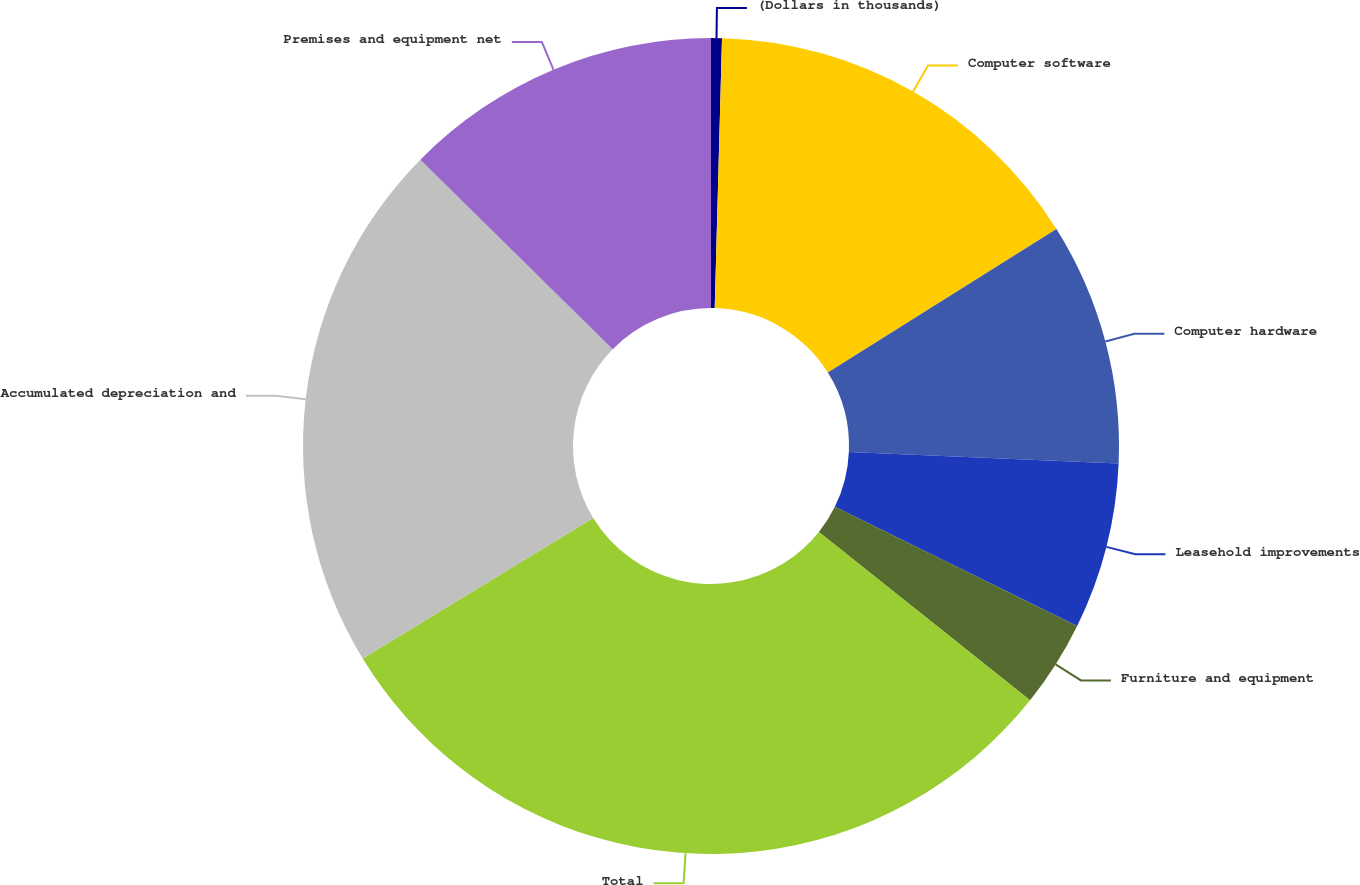<chart> <loc_0><loc_0><loc_500><loc_500><pie_chart><fcel>(Dollars in thousands)<fcel>Computer software<fcel>Computer hardware<fcel>Leasehold improvements<fcel>Furniture and equipment<fcel>Total<fcel>Accumulated depreciation and<fcel>Premises and equipment net<nl><fcel>0.43%<fcel>15.64%<fcel>9.61%<fcel>6.59%<fcel>3.44%<fcel>30.57%<fcel>21.1%<fcel>12.62%<nl></chart> 